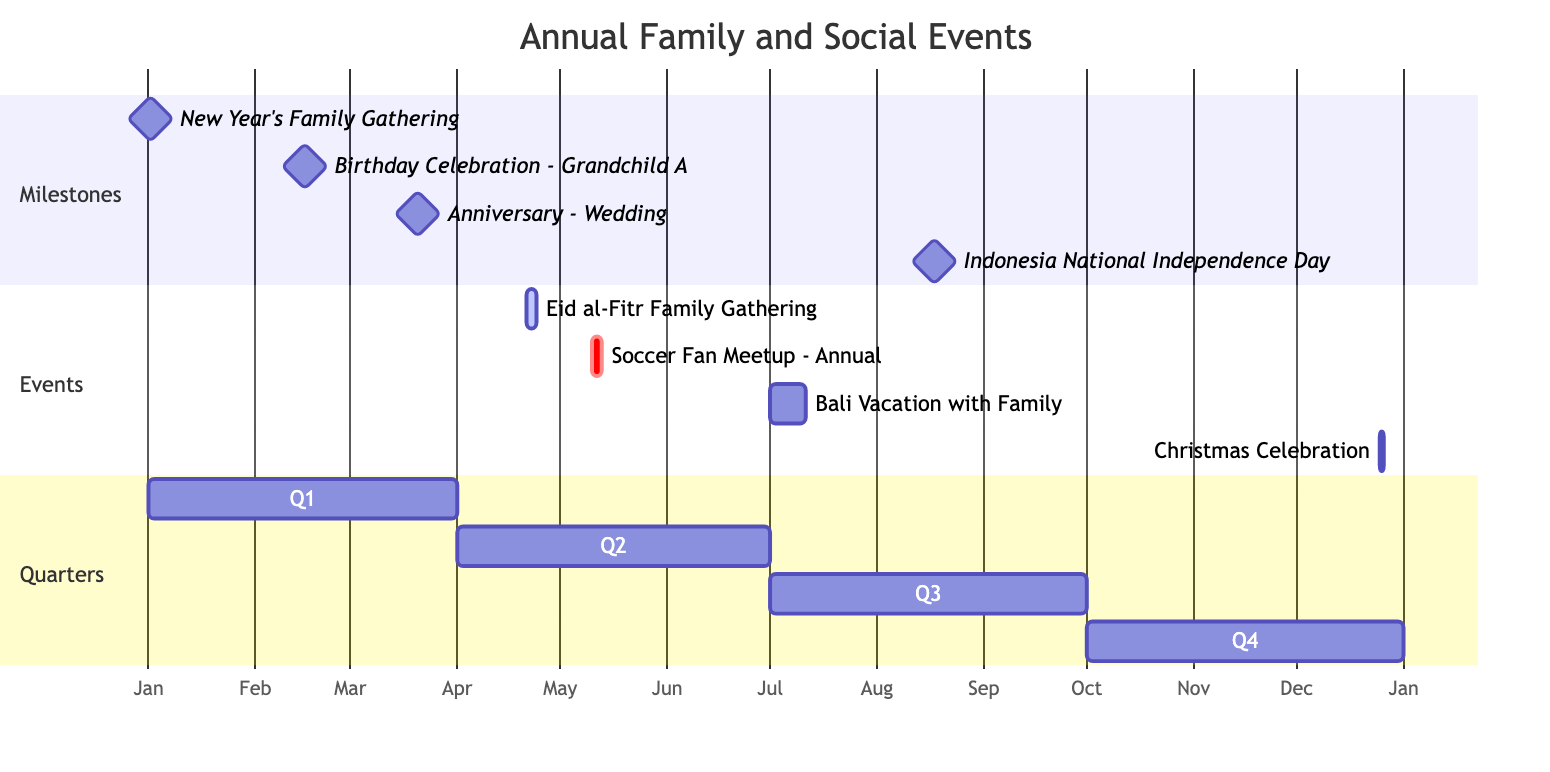What is the duration of the Eid al-Fitr Family Gathering? The Eid al-Fitr Family Gathering starts on April 21, 2023, and ends on April 23, 2023. The difference between the end date and the start date gives a duration of 3 days.
Answer: 3 days Which event occurs in Q1 of 2023? Q1 of 2023 spans from January 1 to March 31. The relevant events include the New Year's Family Gathering (January 1), Birthday Celebration - Grandchild A (February 15), and Anniversary - Wedding (March 20). Therefore, multiple events occur in Q1.
Answer: New Year's Family Gathering, Birthday Celebration - Grandchild A, Anniversary - Wedding What milestone event happens on March 20? Upon reviewing the diagram, it shows that the milestone event scheduled for March 20, 2023, is the Anniversary - Wedding. This can be identified in the Milestones section of the Gantt Chart.
Answer: Anniversary - Wedding How many total events are there in the Gantt Chart? There are a total of 8 events listed in the diagram: 4 milestone events and 4 regular events. By counting each event type, this adds up to 8 in total.
Answer: 8 What is the longest event duration listed in the Gantt Chart? The longest event is the Bali Vacation with Family, which takes place from July 1 to July 10, resulting in a duration of 10 days. This is longer than the other events in the diagram.
Answer: 10 days Which event is scheduled for August 17, 2023? The event listed for August 17, 2023, is the Indonesia National Independence Day Celebration. It is marked as a milestone in the Gantt Chart.
Answer: Indonesia National Independence Day Celebration Is the Soccer Fan Meetup a milestone event? The Soccer Fan Meetup is categorized under Events rather than Milestones. Therefore, it is not a milestone event in the Gantt Chart.
Answer: No What is the starting date of the Christmas Celebration? The Christmas Celebration is scheduled to start on December 25, 2023, as indicated in the Events section of the diagram.
Answer: December 25, 2023 